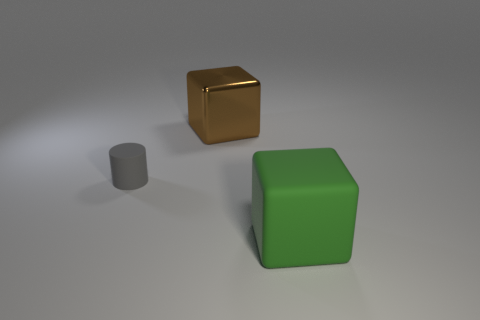Are there any other things that are the same size as the gray matte cylinder?
Offer a very short reply. No. What number of other objects are the same color as the cylinder?
Your answer should be very brief. 0. There is a cube in front of the brown block; is its size the same as the cylinder?
Give a very brief answer. No. Is the material of the block that is behind the gray cylinder the same as the block in front of the brown metallic thing?
Your answer should be very brief. No. Is there a cylinder that has the same size as the rubber cube?
Offer a terse response. No. There is a thing that is left of the large block that is behind the matte object to the left of the big brown metal thing; what is its shape?
Offer a terse response. Cylinder. Is the number of big matte things that are on the left side of the gray matte thing greater than the number of tiny green matte cubes?
Ensure brevity in your answer.  No. Are there any other shiny objects that have the same shape as the brown object?
Your answer should be compact. No. Does the brown thing have the same material as the large cube to the right of the shiny block?
Ensure brevity in your answer.  No. The small rubber thing is what color?
Offer a terse response. Gray. 